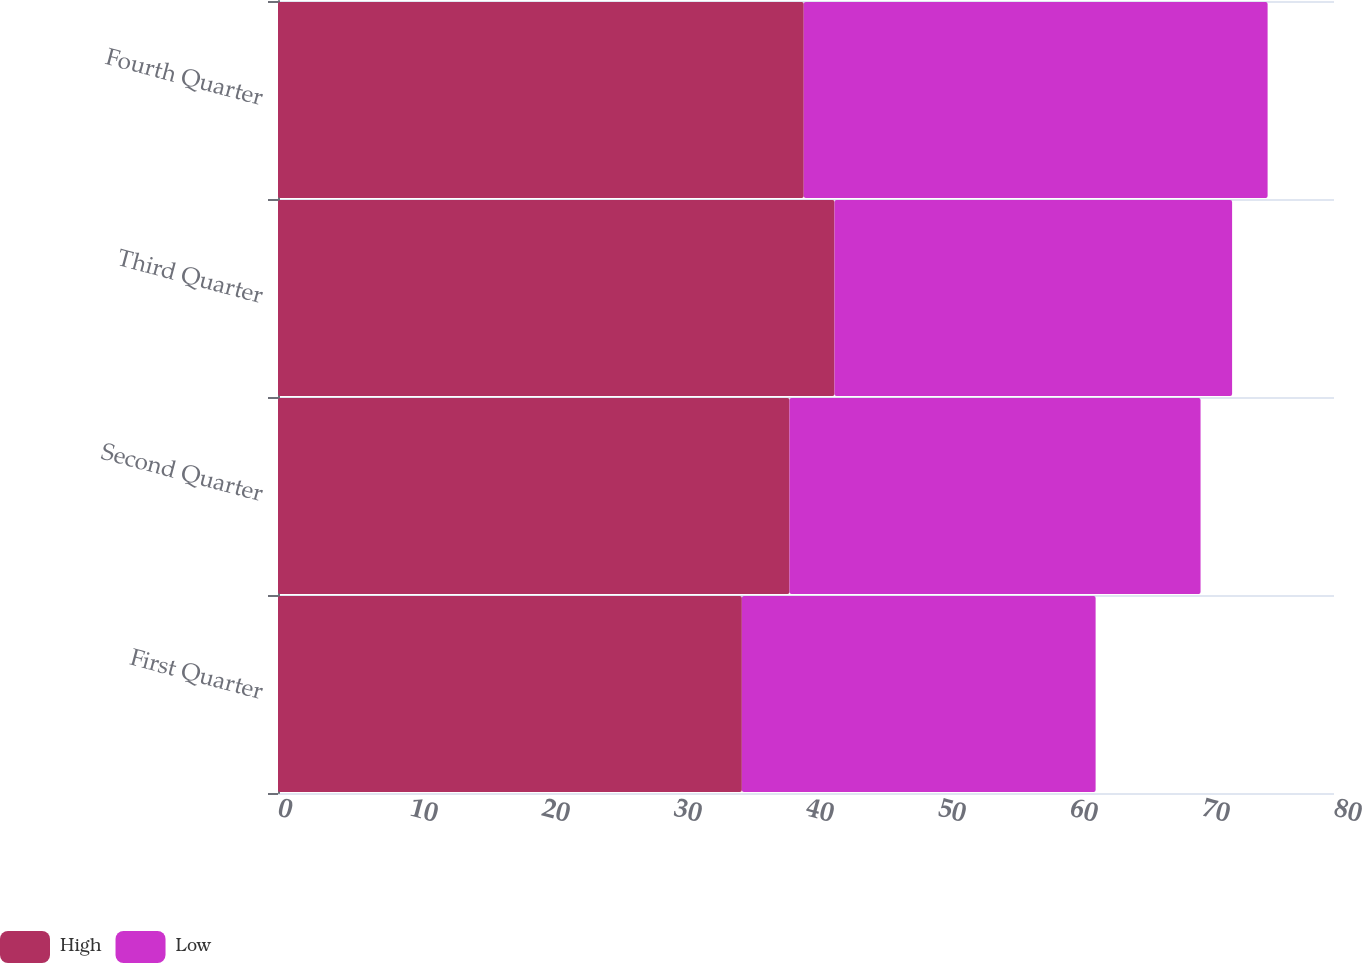<chart> <loc_0><loc_0><loc_500><loc_500><stacked_bar_chart><ecel><fcel>First Quarter<fcel>Second Quarter<fcel>Third Quarter<fcel>Fourth Quarter<nl><fcel>High<fcel>35.14<fcel>38.75<fcel>42.16<fcel>39.83<nl><fcel>Low<fcel>26.8<fcel>31.14<fcel>30.12<fcel>35.14<nl></chart> 